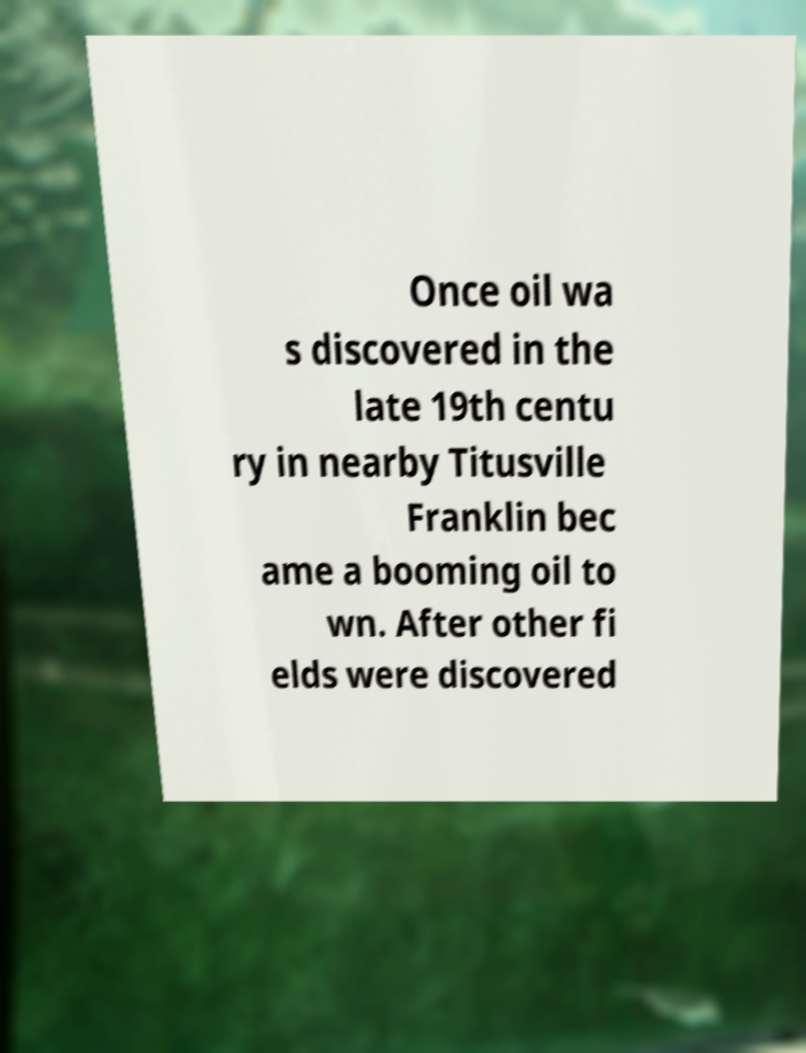Could you assist in decoding the text presented in this image and type it out clearly? Once oil wa s discovered in the late 19th centu ry in nearby Titusville Franklin bec ame a booming oil to wn. After other fi elds were discovered 